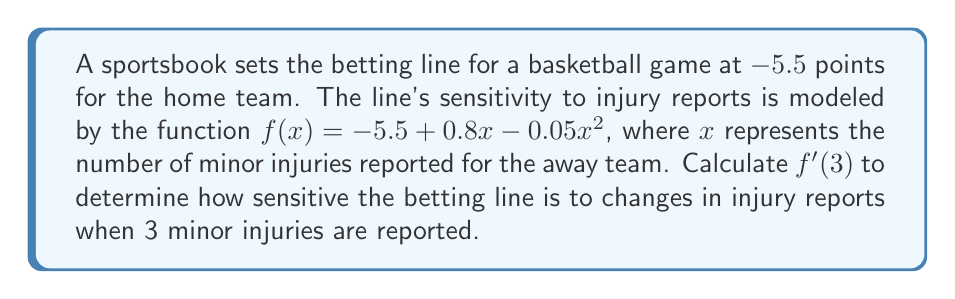Show me your answer to this math problem. To solve this problem, we need to follow these steps:

1) The given function is $f(x) = -5.5 + 0.8x - 0.05x^2$

2) To find $f'(x)$, we need to differentiate $f(x)$ with respect to $x$:
   
   $f'(x) = \frac{d}{dx}(-5.5 + 0.8x - 0.05x^2)$
   
   $f'(x) = 0 + 0.8 - 0.1x$ (using the power rule)

3) Simplify:
   
   $f'(x) = 0.8 - 0.1x$

4) Now, we need to calculate $f'(3)$, which means we substitute $x=3$ into our derivative function:

   $f'(3) = 0.8 - 0.1(3)$
   
   $f'(3) = 0.8 - 0.3 = 0.5$

5) Interpret the result: When 3 minor injuries are reported, the betting line changes by 0.5 points for each additional minor injury reported.
Answer: $0.5$ 